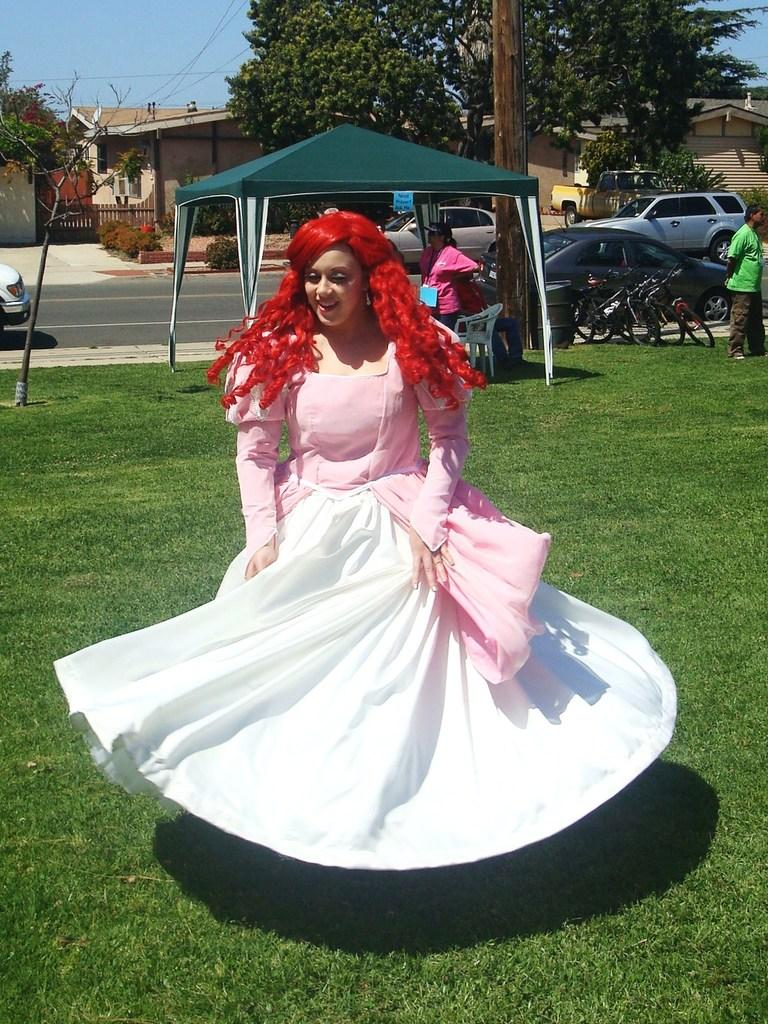How many people can be seen in the image? There are people in the image, but the exact number is not specified. What type of terrain is visible in the image? There is grass in the image, which suggests a natural setting. What type of shelter is present in the image? There is a tent in the image, which could be used for temporary accommodation. What type of transportation is visible in the image? There are vehicles in the image, but their specific types are not mentioned. What type of pathway is present in the image? There is a road in the image, which could be used for vehicular traffic. What type of structure is present in the image? There is a pole in the image, which could be used for various purposes such as signage or lighting. What type of vegetation is present in the image? There is a plant in the image, but its specific type is not mentioned. What type of residential area is visible in the background of the image? In the background of the image, there are houses, which suggests a residential area. What type of vegetation is visible in the background of the image? There are trees and plants in the background of the image, which suggests a natural setting. What type of barrier is present in the background of the image? There is a fence in the background of the image, which could be used for various purposes such as marking boundaries or providing privacy. What type of sky is visible in the background of the image? There is sky visible in the background of the image, but its specific appearance is not mentioned. How many screws can be seen holding the game together in the image? There is no game or screws present in the image. Can you describe the scarecrow in the image? There is no scarecrow present in the image. 